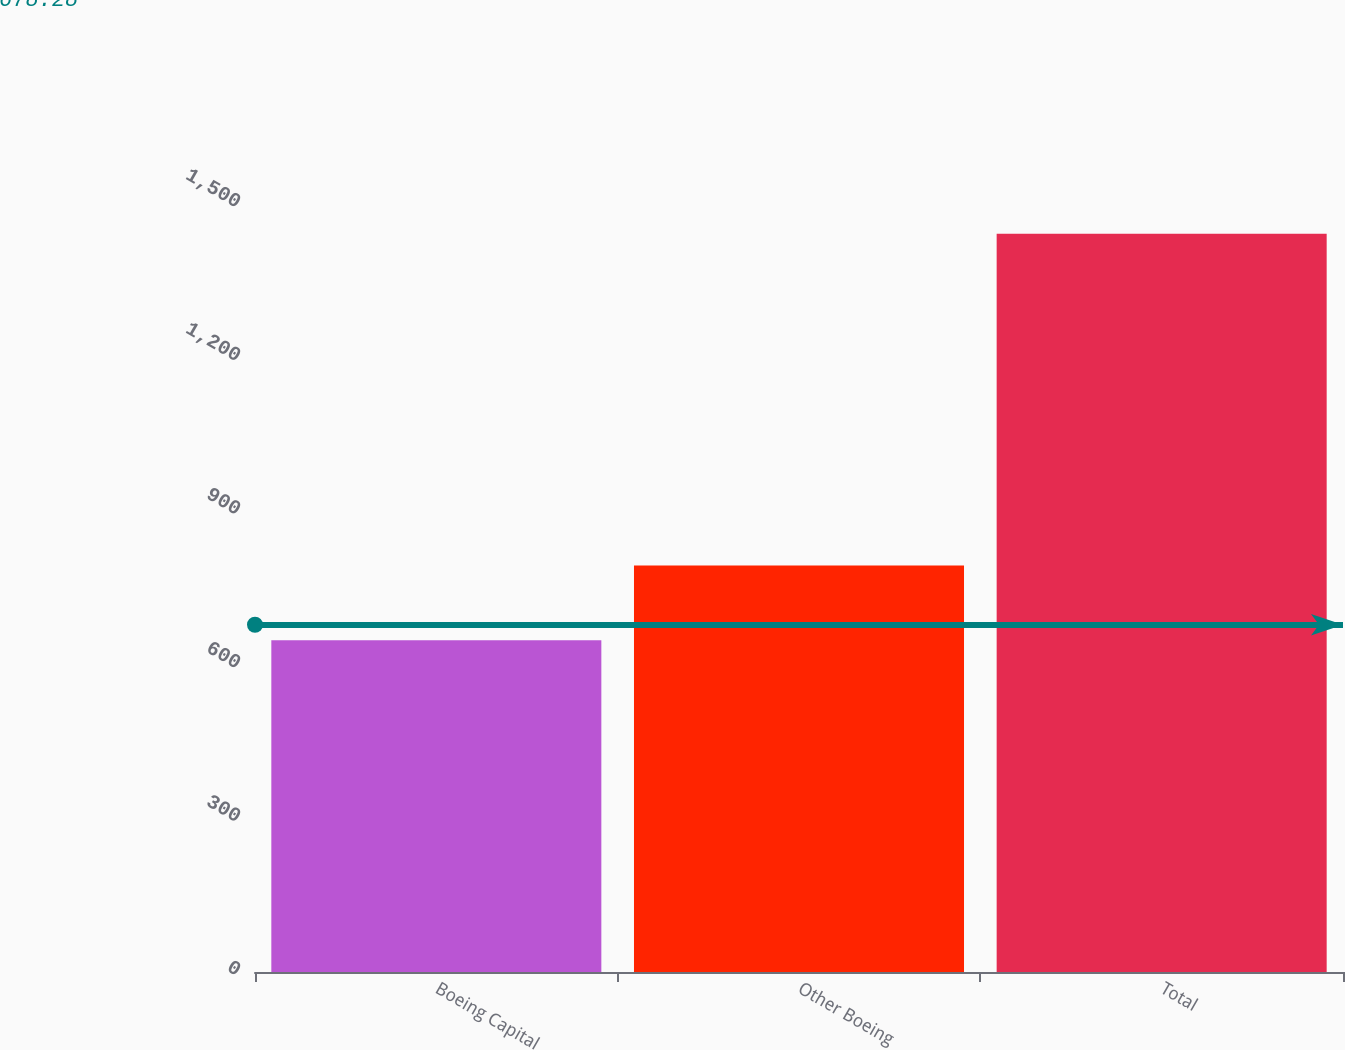<chart> <loc_0><loc_0><loc_500><loc_500><bar_chart><fcel>Boeing Capital<fcel>Other Boeing<fcel>Total<nl><fcel>648<fcel>794<fcel>1442<nl></chart> 